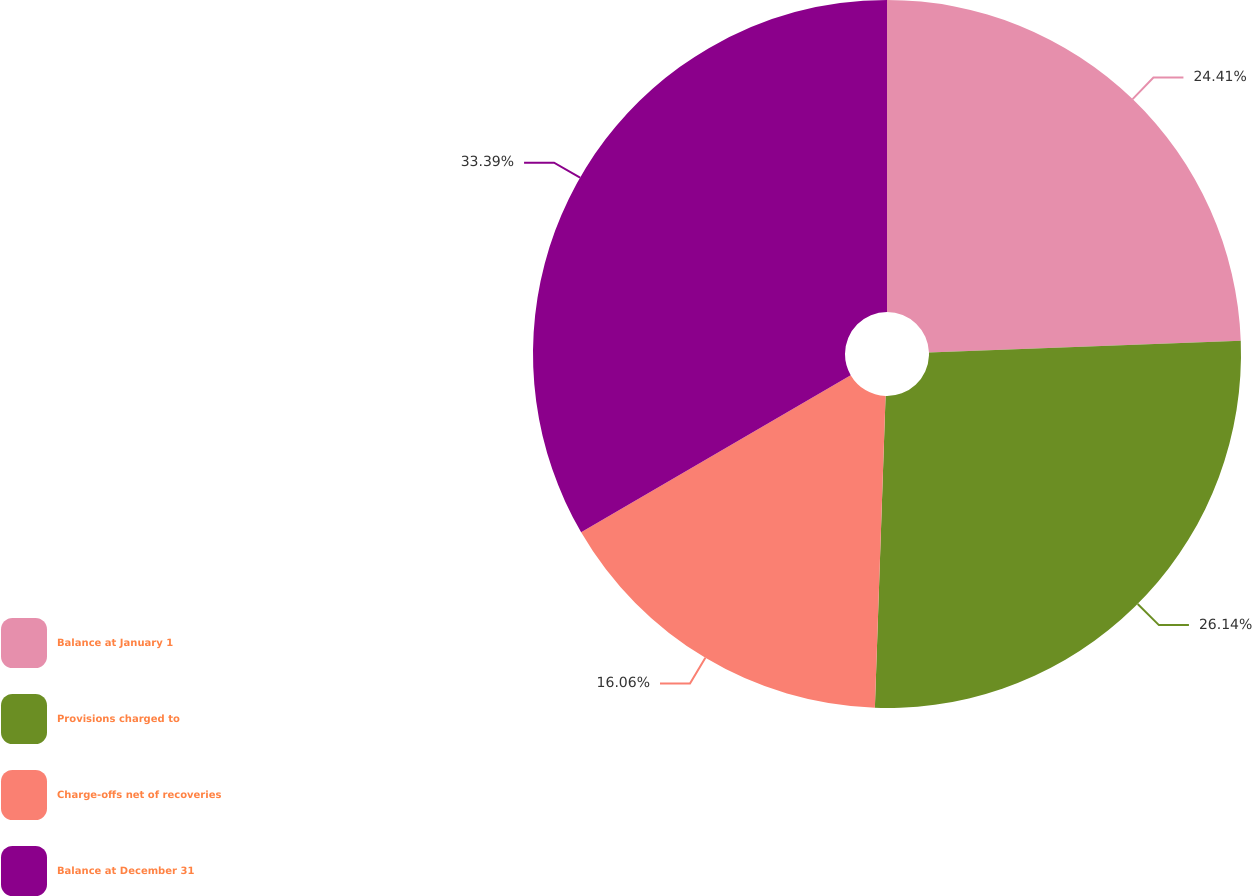Convert chart. <chart><loc_0><loc_0><loc_500><loc_500><pie_chart><fcel>Balance at January 1<fcel>Provisions charged to<fcel>Charge-offs net of recoveries<fcel>Balance at December 31<nl><fcel>24.41%<fcel>26.14%<fcel>16.06%<fcel>33.4%<nl></chart> 